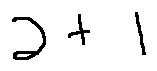Convert formula to latex. <formula><loc_0><loc_0><loc_500><loc_500>2 + 1</formula> 